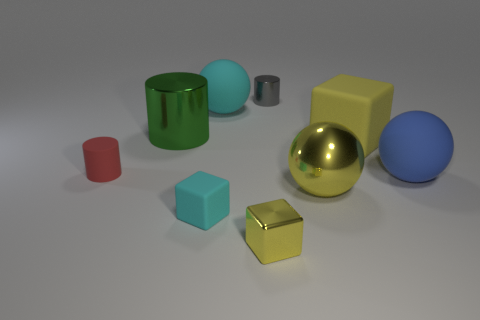Subtract all tiny cubes. How many cubes are left? 1 Subtract all yellow blocks. How many blocks are left? 1 Subtract 3 cylinders. How many cylinders are left? 0 Subtract all cubes. How many objects are left? 6 Subtract all gray balls. Subtract all gray cylinders. How many balls are left? 3 Subtract all yellow cubes. How many yellow spheres are left? 1 Subtract all small yellow shiny objects. Subtract all small blue matte cubes. How many objects are left? 8 Add 6 small matte objects. How many small matte objects are left? 8 Add 3 large cyan shiny cylinders. How many large cyan shiny cylinders exist? 3 Subtract 1 green cylinders. How many objects are left? 8 